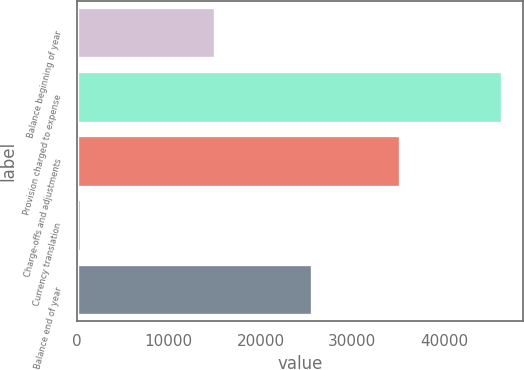Convert chart to OTSL. <chart><loc_0><loc_0><loc_500><loc_500><bar_chart><fcel>Balance beginning of year<fcel>Provision charged to expense<fcel>Charge-offs and adjustments<fcel>Currency translation<fcel>Balance end of year<nl><fcel>15014<fcel>46241<fcel>35233<fcel>457<fcel>25565<nl></chart> 